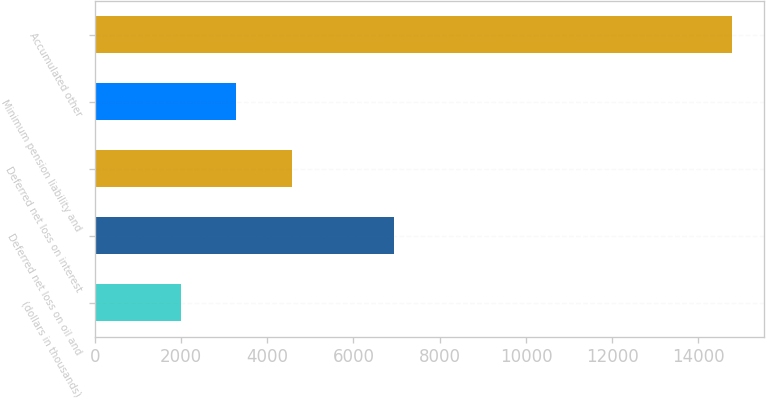Convert chart to OTSL. <chart><loc_0><loc_0><loc_500><loc_500><bar_chart><fcel>(dollars in thousands)<fcel>Deferred net loss on oil and<fcel>Deferred net loss on interest<fcel>Minimum pension liability and<fcel>Accumulated other<nl><fcel>2004<fcel>6939<fcel>4577<fcel>3282.3<fcel>14787<nl></chart> 